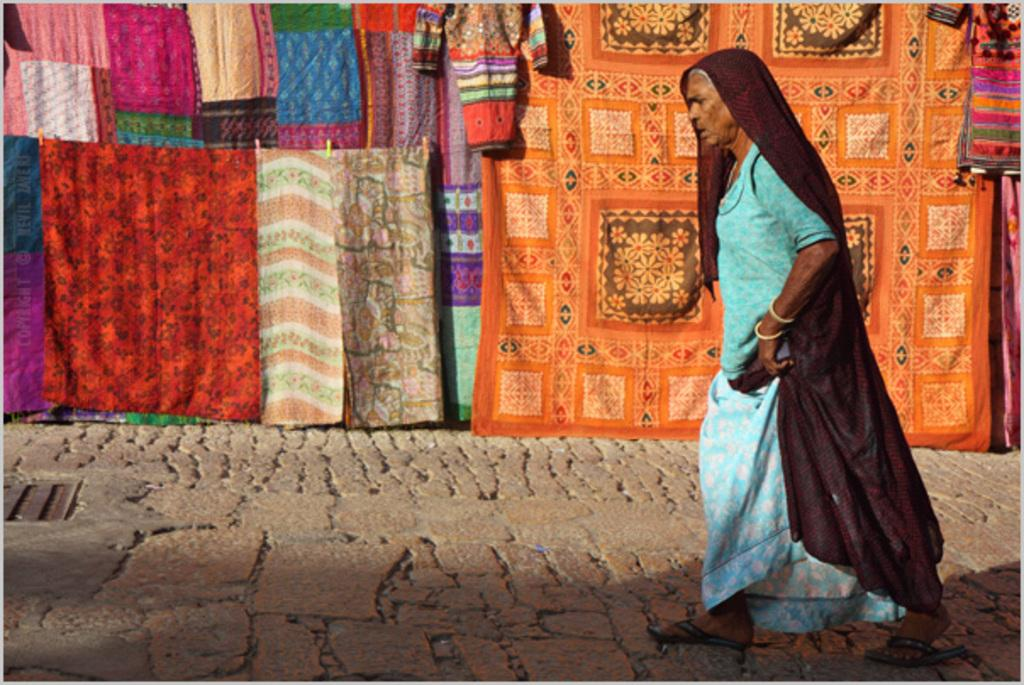What is the lady in the image doing? The lady is walking on the right side of the image. What can be seen in the background of the image? There are clothes hanging and clips visible in the background of the image. What type of science experiment is being conducted in the image? There is no science experiment present in the image; it features a lady walking and clothes hanging in the background. What is the lady's insurance status in the image? There is no information about the lady's insurance status in the image. 